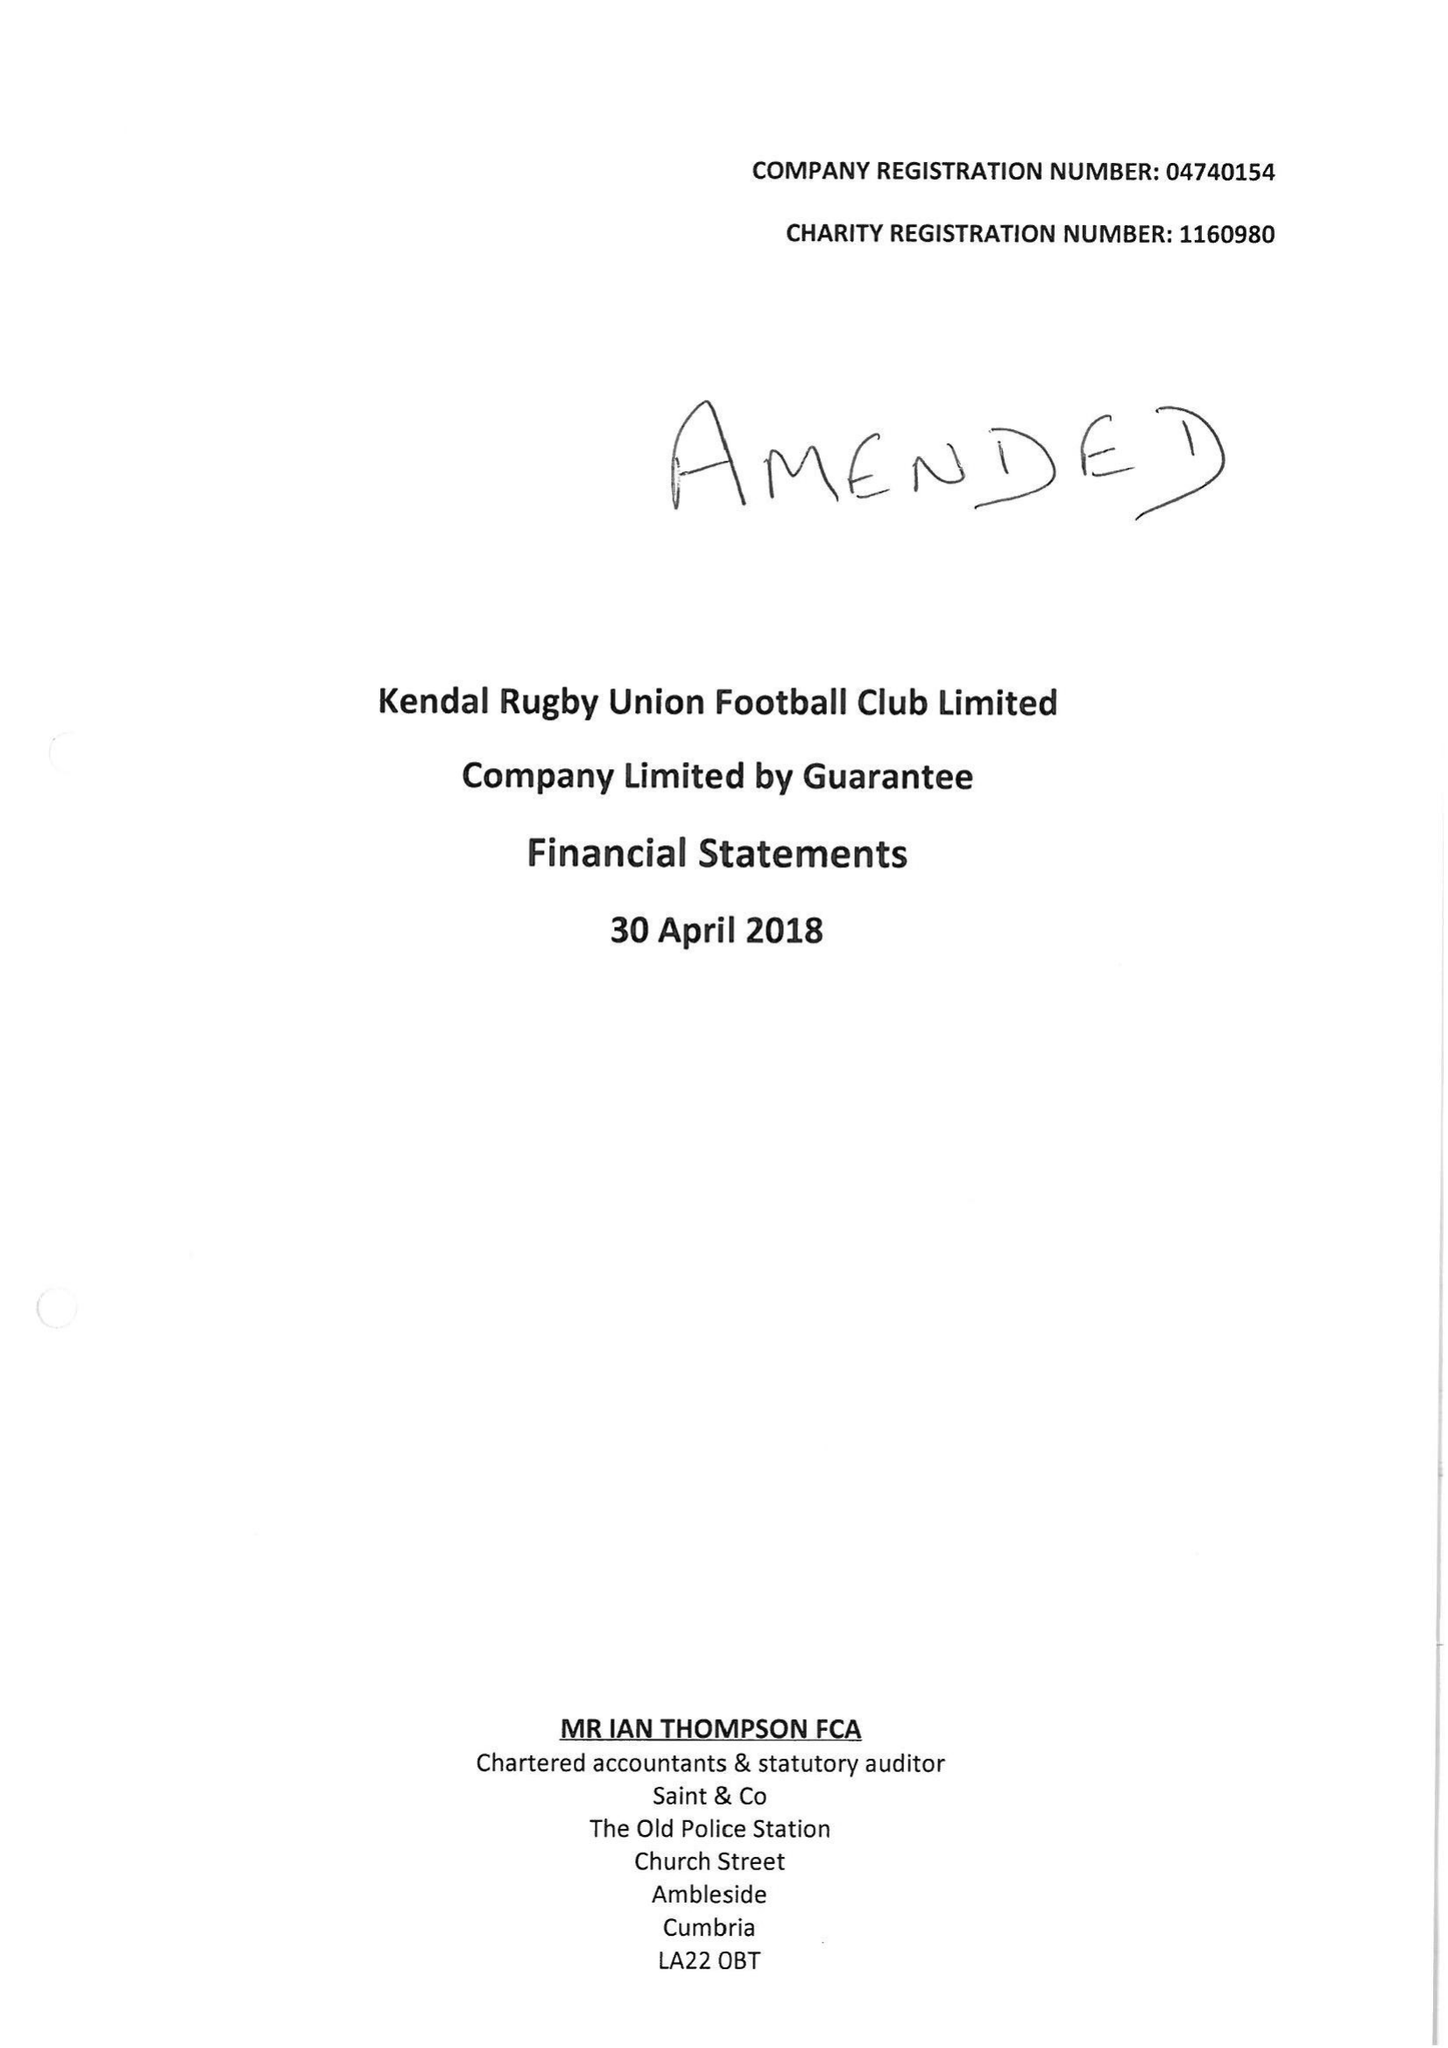What is the value for the charity_number?
Answer the question using a single word or phrase. 1160980 